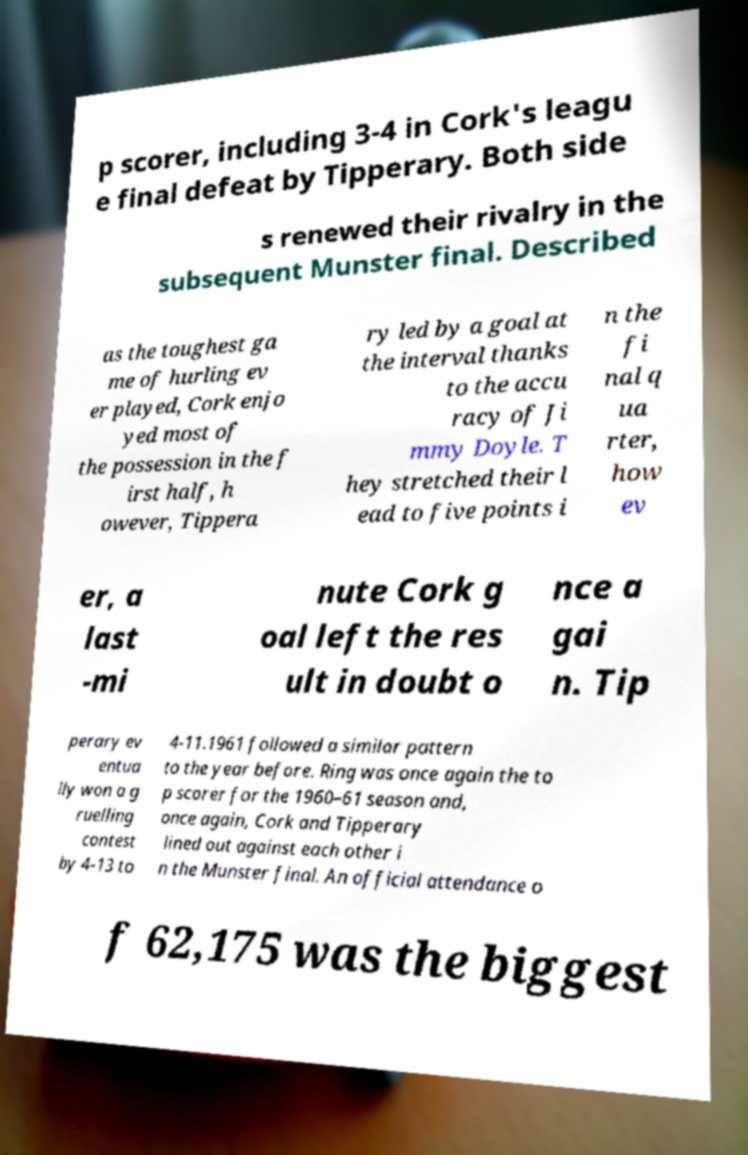Could you assist in decoding the text presented in this image and type it out clearly? p scorer, including 3-4 in Cork's leagu e final defeat by Tipperary. Both side s renewed their rivalry in the subsequent Munster final. Described as the toughest ga me of hurling ev er played, Cork enjo yed most of the possession in the f irst half, h owever, Tippera ry led by a goal at the interval thanks to the accu racy of Ji mmy Doyle. T hey stretched their l ead to five points i n the fi nal q ua rter, how ev er, a last -mi nute Cork g oal left the res ult in doubt o nce a gai n. Tip perary ev entua lly won a g ruelling contest by 4-13 to 4-11.1961 followed a similar pattern to the year before. Ring was once again the to p scorer for the 1960–61 season and, once again, Cork and Tipperary lined out against each other i n the Munster final. An official attendance o f 62,175 was the biggest 